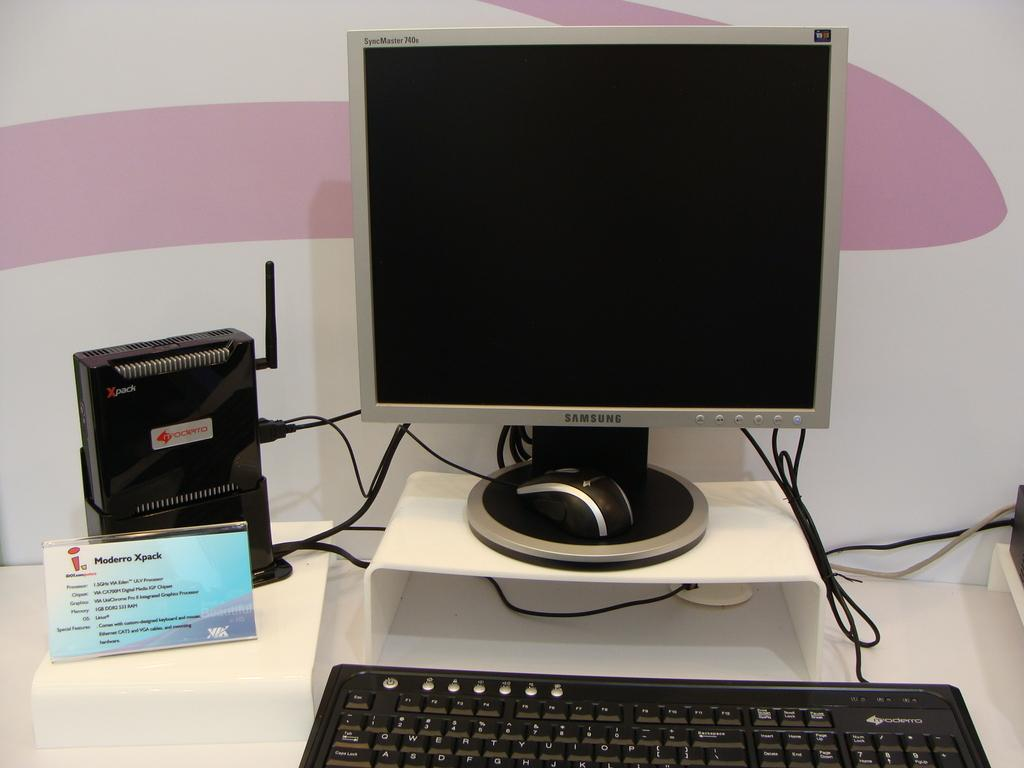<image>
Present a compact description of the photo's key features. A Computer is on display with a Samsung monitor. 